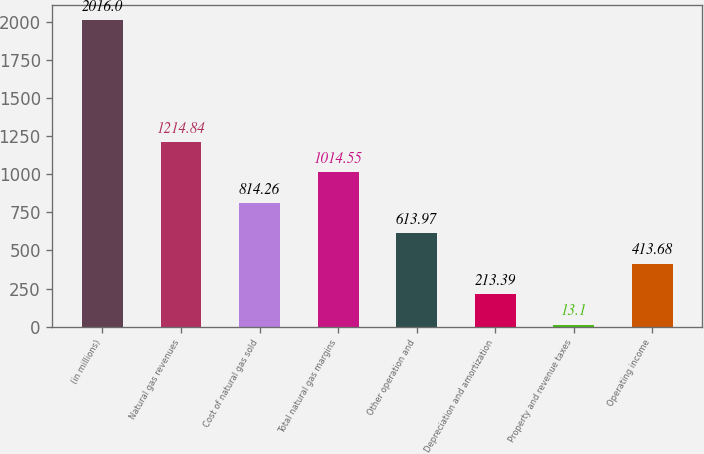<chart> <loc_0><loc_0><loc_500><loc_500><bar_chart><fcel>(in millions)<fcel>Natural gas revenues<fcel>Cost of natural gas sold<fcel>Total natural gas margins<fcel>Other operation and<fcel>Depreciation and amortization<fcel>Property and revenue taxes<fcel>Operating income<nl><fcel>2016<fcel>1214.84<fcel>814.26<fcel>1014.55<fcel>613.97<fcel>213.39<fcel>13.1<fcel>413.68<nl></chart> 